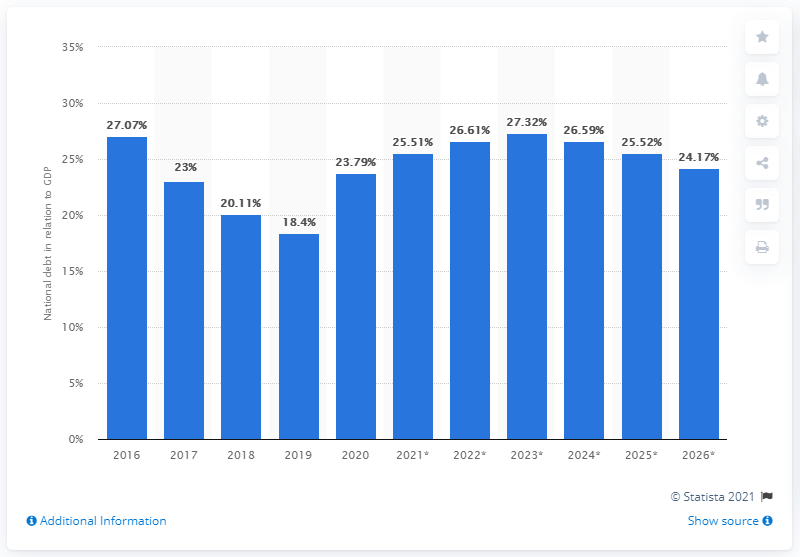Indicate a few pertinent items in this graphic. In 2020, the national debt of Bulgaria accounted for approximately 23.79% of the country's Gross Domestic Product (GDP). 